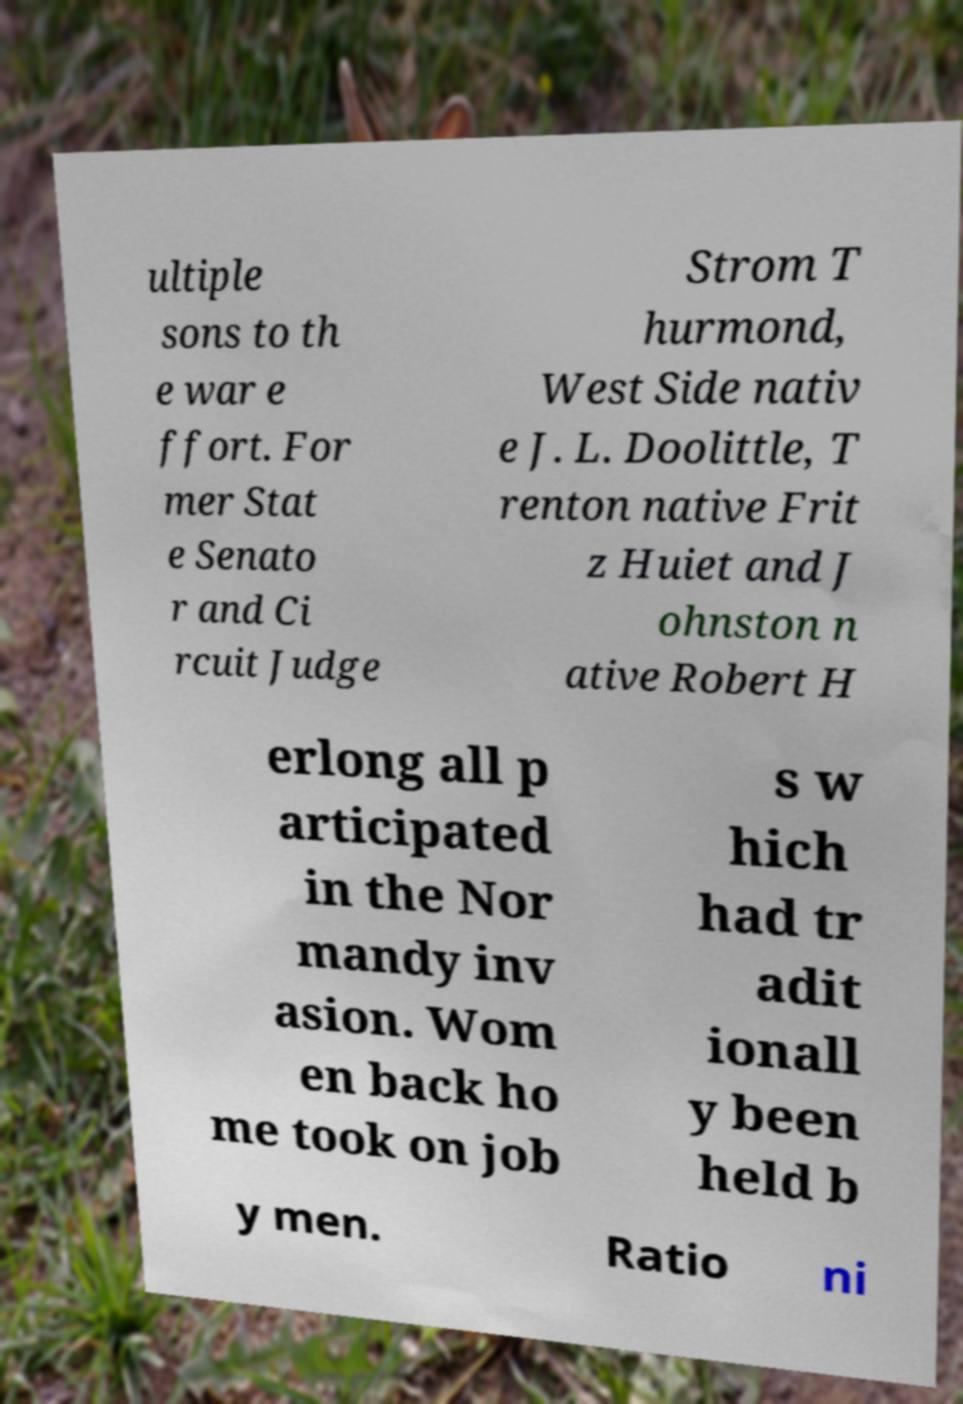Can you accurately transcribe the text from the provided image for me? ultiple sons to th e war e ffort. For mer Stat e Senato r and Ci rcuit Judge Strom T hurmond, West Side nativ e J. L. Doolittle, T renton native Frit z Huiet and J ohnston n ative Robert H erlong all p articipated in the Nor mandy inv asion. Wom en back ho me took on job s w hich had tr adit ionall y been held b y men. Ratio ni 